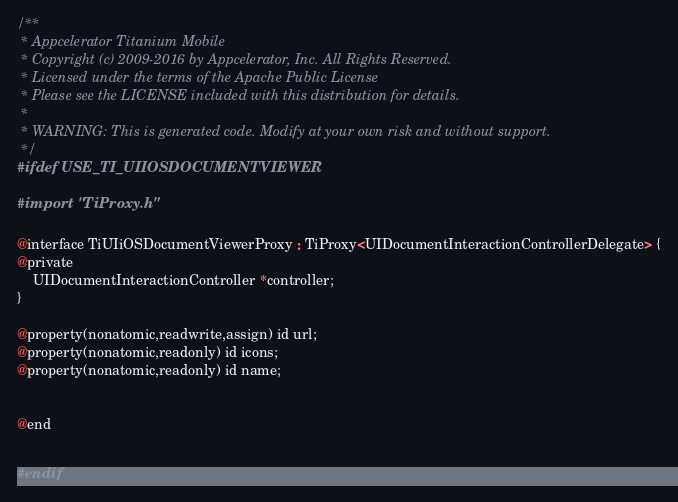Convert code to text. <code><loc_0><loc_0><loc_500><loc_500><_C_>/**
 * Appcelerator Titanium Mobile
 * Copyright (c) 2009-2016 by Appcelerator, Inc. All Rights Reserved.
 * Licensed under the terms of the Apache Public License
 * Please see the LICENSE included with this distribution for details.
 * 
 * WARNING: This is generated code. Modify at your own risk and without support.
 */
#ifdef USE_TI_UIIOSDOCUMENTVIEWER

#import "TiProxy.h"

@interface TiUIiOSDocumentViewerProxy : TiProxy<UIDocumentInteractionControllerDelegate> {
@private
	UIDocumentInteractionController *controller;
}

@property(nonatomic,readwrite,assign) id url;
@property(nonatomic,readonly) id icons;
@property(nonatomic,readonly) id name;


@end


#endif
</code> 